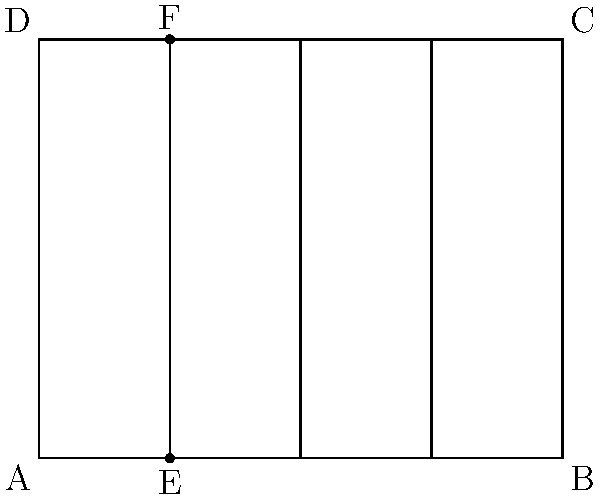In a traditional Italian vineyard near Sassoleone, grapevines are planted in rows as shown in the diagram. The rectangular vineyard measures 100 meters in length and 80 meters in width. If the rows are equally spaced and the distance between point E and point A is 25 meters, what is the total length of wire needed to support all the rows of grapevines, assuming the wire runs from one end of the row to the other? Let's approach this step-by-step:

1) First, we need to determine how many rows of grapevines there are:
   - The distance between A and E is 25 meters
   - The total length of the vineyard is 100 meters
   - So, the number of rows = $100 \div 25 = 4$ rows

2) Now, we need to calculate the length of each row:
   - The width of the vineyard is 80 meters
   - Each row runs the full width of the vineyard
   - So, the length of each row = 80 meters

3) To find the total length of wire needed, we multiply the number of rows by the length of each row:
   $4 \times 80 = 320$ meters

Therefore, the total length of wire needed to support all the rows of grapevines is 320 meters.
Answer: 320 meters 